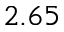<formula> <loc_0><loc_0><loc_500><loc_500>2 . 6 5</formula> 